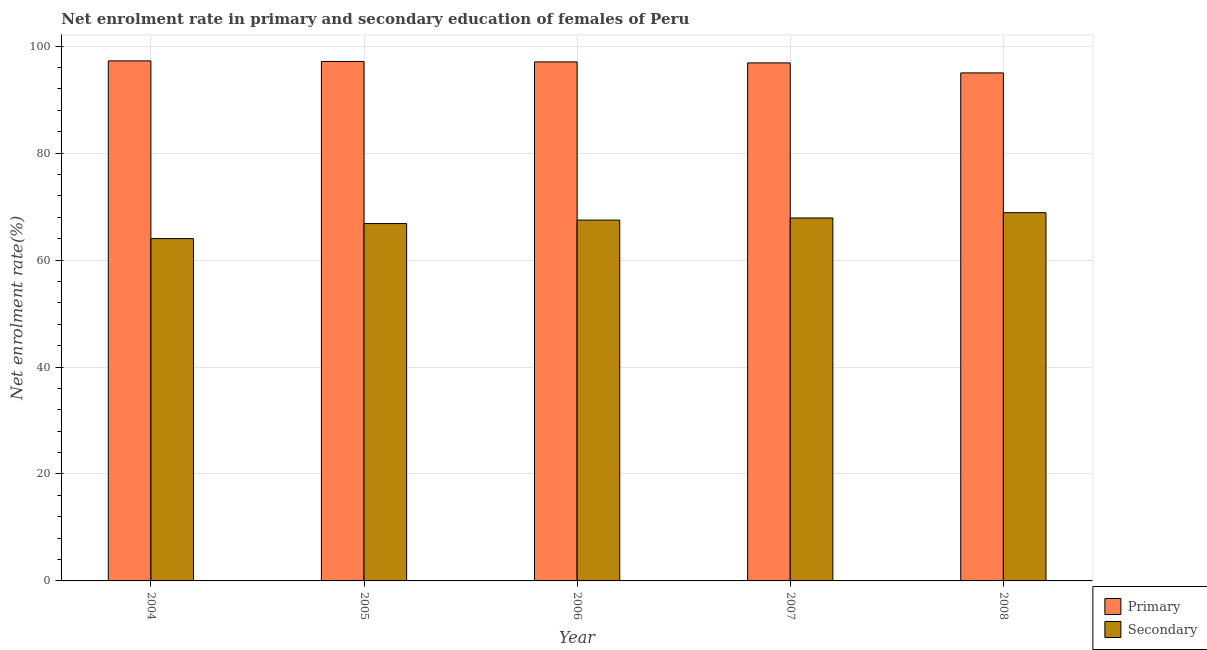How many different coloured bars are there?
Your answer should be very brief. 2. Are the number of bars per tick equal to the number of legend labels?
Provide a succinct answer. Yes. Are the number of bars on each tick of the X-axis equal?
Offer a very short reply. Yes. What is the label of the 4th group of bars from the left?
Offer a terse response. 2007. In how many cases, is the number of bars for a given year not equal to the number of legend labels?
Provide a short and direct response. 0. What is the enrollment rate in primary education in 2006?
Your answer should be compact. 97.05. Across all years, what is the maximum enrollment rate in secondary education?
Make the answer very short. 68.86. Across all years, what is the minimum enrollment rate in primary education?
Your response must be concise. 95. In which year was the enrollment rate in secondary education minimum?
Offer a terse response. 2004. What is the total enrollment rate in secondary education in the graph?
Your answer should be very brief. 335.04. What is the difference between the enrollment rate in primary education in 2006 and that in 2008?
Your answer should be compact. 2.05. What is the difference between the enrollment rate in secondary education in 2008 and the enrollment rate in primary education in 2007?
Offer a very short reply. 0.99. What is the average enrollment rate in secondary education per year?
Your response must be concise. 67.01. In the year 2005, what is the difference between the enrollment rate in secondary education and enrollment rate in primary education?
Make the answer very short. 0. In how many years, is the enrollment rate in secondary education greater than 84 %?
Your answer should be compact. 0. What is the ratio of the enrollment rate in secondary education in 2004 to that in 2005?
Provide a short and direct response. 0.96. Is the difference between the enrollment rate in secondary education in 2005 and 2006 greater than the difference between the enrollment rate in primary education in 2005 and 2006?
Keep it short and to the point. No. What is the difference between the highest and the second highest enrollment rate in primary education?
Ensure brevity in your answer.  0.11. What is the difference between the highest and the lowest enrollment rate in primary education?
Keep it short and to the point. 2.25. What does the 2nd bar from the left in 2008 represents?
Make the answer very short. Secondary. What does the 1st bar from the right in 2004 represents?
Keep it short and to the point. Secondary. How many years are there in the graph?
Your response must be concise. 5. Are the values on the major ticks of Y-axis written in scientific E-notation?
Ensure brevity in your answer.  No. Where does the legend appear in the graph?
Offer a terse response. Bottom right. How many legend labels are there?
Your response must be concise. 2. What is the title of the graph?
Keep it short and to the point. Net enrolment rate in primary and secondary education of females of Peru. What is the label or title of the Y-axis?
Provide a short and direct response. Net enrolment rate(%). What is the Net enrolment rate(%) in Primary in 2004?
Offer a very short reply. 97.25. What is the Net enrolment rate(%) in Secondary in 2004?
Give a very brief answer. 64.02. What is the Net enrolment rate(%) of Primary in 2005?
Ensure brevity in your answer.  97.14. What is the Net enrolment rate(%) in Secondary in 2005?
Provide a succinct answer. 66.82. What is the Net enrolment rate(%) of Primary in 2006?
Your response must be concise. 97.05. What is the Net enrolment rate(%) of Secondary in 2006?
Offer a very short reply. 67.47. What is the Net enrolment rate(%) in Primary in 2007?
Offer a terse response. 96.87. What is the Net enrolment rate(%) of Secondary in 2007?
Provide a succinct answer. 67.87. What is the Net enrolment rate(%) of Primary in 2008?
Keep it short and to the point. 95. What is the Net enrolment rate(%) in Secondary in 2008?
Provide a short and direct response. 68.86. Across all years, what is the maximum Net enrolment rate(%) in Primary?
Your answer should be compact. 97.25. Across all years, what is the maximum Net enrolment rate(%) of Secondary?
Keep it short and to the point. 68.86. Across all years, what is the minimum Net enrolment rate(%) in Primary?
Give a very brief answer. 95. Across all years, what is the minimum Net enrolment rate(%) in Secondary?
Make the answer very short. 64.02. What is the total Net enrolment rate(%) in Primary in the graph?
Keep it short and to the point. 483.3. What is the total Net enrolment rate(%) of Secondary in the graph?
Your answer should be very brief. 335.04. What is the difference between the Net enrolment rate(%) of Primary in 2004 and that in 2005?
Your answer should be very brief. 0.11. What is the difference between the Net enrolment rate(%) in Secondary in 2004 and that in 2005?
Your response must be concise. -2.81. What is the difference between the Net enrolment rate(%) of Primary in 2004 and that in 2006?
Provide a short and direct response. 0.19. What is the difference between the Net enrolment rate(%) of Secondary in 2004 and that in 2006?
Your response must be concise. -3.46. What is the difference between the Net enrolment rate(%) of Primary in 2004 and that in 2007?
Keep it short and to the point. 0.38. What is the difference between the Net enrolment rate(%) in Secondary in 2004 and that in 2007?
Your response must be concise. -3.85. What is the difference between the Net enrolment rate(%) in Primary in 2004 and that in 2008?
Make the answer very short. 2.25. What is the difference between the Net enrolment rate(%) of Secondary in 2004 and that in 2008?
Make the answer very short. -4.84. What is the difference between the Net enrolment rate(%) of Primary in 2005 and that in 2006?
Your answer should be compact. 0.08. What is the difference between the Net enrolment rate(%) in Secondary in 2005 and that in 2006?
Offer a terse response. -0.65. What is the difference between the Net enrolment rate(%) in Primary in 2005 and that in 2007?
Provide a succinct answer. 0.27. What is the difference between the Net enrolment rate(%) of Secondary in 2005 and that in 2007?
Offer a very short reply. -1.05. What is the difference between the Net enrolment rate(%) in Primary in 2005 and that in 2008?
Your answer should be very brief. 2.14. What is the difference between the Net enrolment rate(%) of Secondary in 2005 and that in 2008?
Your answer should be very brief. -2.03. What is the difference between the Net enrolment rate(%) of Primary in 2006 and that in 2007?
Your answer should be compact. 0.18. What is the difference between the Net enrolment rate(%) of Secondary in 2006 and that in 2007?
Your answer should be compact. -0.4. What is the difference between the Net enrolment rate(%) in Primary in 2006 and that in 2008?
Your answer should be very brief. 2.05. What is the difference between the Net enrolment rate(%) in Secondary in 2006 and that in 2008?
Provide a succinct answer. -1.38. What is the difference between the Net enrolment rate(%) of Primary in 2007 and that in 2008?
Keep it short and to the point. 1.87. What is the difference between the Net enrolment rate(%) of Secondary in 2007 and that in 2008?
Provide a short and direct response. -0.99. What is the difference between the Net enrolment rate(%) of Primary in 2004 and the Net enrolment rate(%) of Secondary in 2005?
Offer a terse response. 30.42. What is the difference between the Net enrolment rate(%) of Primary in 2004 and the Net enrolment rate(%) of Secondary in 2006?
Offer a very short reply. 29.77. What is the difference between the Net enrolment rate(%) in Primary in 2004 and the Net enrolment rate(%) in Secondary in 2007?
Provide a succinct answer. 29.38. What is the difference between the Net enrolment rate(%) in Primary in 2004 and the Net enrolment rate(%) in Secondary in 2008?
Ensure brevity in your answer.  28.39. What is the difference between the Net enrolment rate(%) of Primary in 2005 and the Net enrolment rate(%) of Secondary in 2006?
Your answer should be very brief. 29.66. What is the difference between the Net enrolment rate(%) in Primary in 2005 and the Net enrolment rate(%) in Secondary in 2007?
Make the answer very short. 29.27. What is the difference between the Net enrolment rate(%) in Primary in 2005 and the Net enrolment rate(%) in Secondary in 2008?
Offer a terse response. 28.28. What is the difference between the Net enrolment rate(%) in Primary in 2006 and the Net enrolment rate(%) in Secondary in 2007?
Your response must be concise. 29.18. What is the difference between the Net enrolment rate(%) of Primary in 2006 and the Net enrolment rate(%) of Secondary in 2008?
Your answer should be very brief. 28.2. What is the difference between the Net enrolment rate(%) of Primary in 2007 and the Net enrolment rate(%) of Secondary in 2008?
Ensure brevity in your answer.  28.01. What is the average Net enrolment rate(%) of Primary per year?
Provide a succinct answer. 96.66. What is the average Net enrolment rate(%) in Secondary per year?
Your response must be concise. 67.01. In the year 2004, what is the difference between the Net enrolment rate(%) of Primary and Net enrolment rate(%) of Secondary?
Give a very brief answer. 33.23. In the year 2005, what is the difference between the Net enrolment rate(%) in Primary and Net enrolment rate(%) in Secondary?
Make the answer very short. 30.31. In the year 2006, what is the difference between the Net enrolment rate(%) in Primary and Net enrolment rate(%) in Secondary?
Offer a terse response. 29.58. In the year 2007, what is the difference between the Net enrolment rate(%) of Primary and Net enrolment rate(%) of Secondary?
Give a very brief answer. 29. In the year 2008, what is the difference between the Net enrolment rate(%) in Primary and Net enrolment rate(%) in Secondary?
Ensure brevity in your answer.  26.14. What is the ratio of the Net enrolment rate(%) of Primary in 2004 to that in 2005?
Make the answer very short. 1. What is the ratio of the Net enrolment rate(%) in Secondary in 2004 to that in 2005?
Keep it short and to the point. 0.96. What is the ratio of the Net enrolment rate(%) of Secondary in 2004 to that in 2006?
Your response must be concise. 0.95. What is the ratio of the Net enrolment rate(%) in Primary in 2004 to that in 2007?
Your answer should be compact. 1. What is the ratio of the Net enrolment rate(%) of Secondary in 2004 to that in 2007?
Provide a short and direct response. 0.94. What is the ratio of the Net enrolment rate(%) in Primary in 2004 to that in 2008?
Your answer should be very brief. 1.02. What is the ratio of the Net enrolment rate(%) of Secondary in 2004 to that in 2008?
Your response must be concise. 0.93. What is the ratio of the Net enrolment rate(%) of Secondary in 2005 to that in 2007?
Provide a succinct answer. 0.98. What is the ratio of the Net enrolment rate(%) of Primary in 2005 to that in 2008?
Ensure brevity in your answer.  1.02. What is the ratio of the Net enrolment rate(%) of Secondary in 2005 to that in 2008?
Offer a very short reply. 0.97. What is the ratio of the Net enrolment rate(%) of Secondary in 2006 to that in 2007?
Give a very brief answer. 0.99. What is the ratio of the Net enrolment rate(%) in Primary in 2006 to that in 2008?
Your answer should be compact. 1.02. What is the ratio of the Net enrolment rate(%) of Secondary in 2006 to that in 2008?
Offer a terse response. 0.98. What is the ratio of the Net enrolment rate(%) in Primary in 2007 to that in 2008?
Your answer should be compact. 1.02. What is the ratio of the Net enrolment rate(%) in Secondary in 2007 to that in 2008?
Provide a succinct answer. 0.99. What is the difference between the highest and the second highest Net enrolment rate(%) of Primary?
Offer a terse response. 0.11. What is the difference between the highest and the second highest Net enrolment rate(%) of Secondary?
Provide a short and direct response. 0.99. What is the difference between the highest and the lowest Net enrolment rate(%) of Primary?
Your answer should be compact. 2.25. What is the difference between the highest and the lowest Net enrolment rate(%) of Secondary?
Make the answer very short. 4.84. 